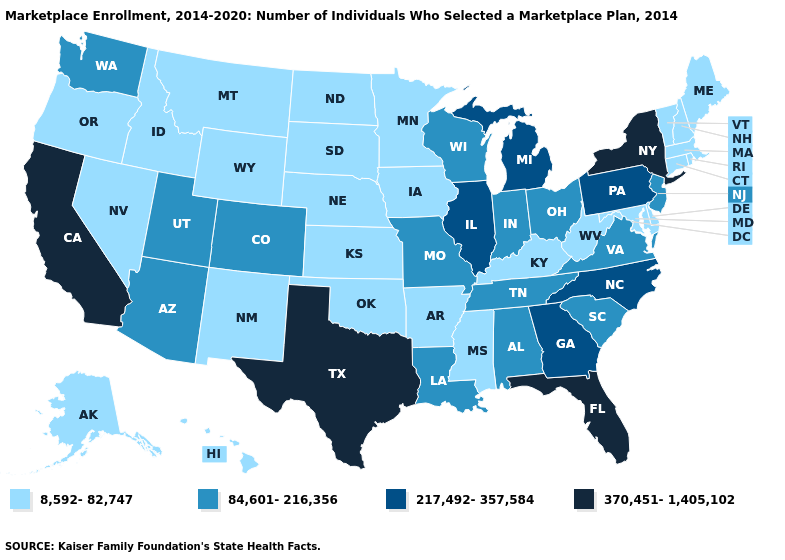What is the value of Alabama?
Answer briefly. 84,601-216,356. Which states hav the highest value in the South?
Write a very short answer. Florida, Texas. Among the states that border Colorado , does Oklahoma have the highest value?
Concise answer only. No. Which states have the lowest value in the MidWest?
Write a very short answer. Iowa, Kansas, Minnesota, Nebraska, North Dakota, South Dakota. Does the first symbol in the legend represent the smallest category?
Give a very brief answer. Yes. Does the first symbol in the legend represent the smallest category?
Keep it brief. Yes. What is the value of Iowa?
Answer briefly. 8,592-82,747. Name the states that have a value in the range 370,451-1,405,102?
Answer briefly. California, Florida, New York, Texas. What is the lowest value in states that border New Hampshire?
Write a very short answer. 8,592-82,747. What is the value of New York?
Concise answer only. 370,451-1,405,102. What is the value of Florida?
Concise answer only. 370,451-1,405,102. Does the map have missing data?
Write a very short answer. No. Among the states that border Wisconsin , which have the highest value?
Keep it brief. Illinois, Michigan. What is the value of Pennsylvania?
Quick response, please. 217,492-357,584. What is the highest value in states that border Iowa?
Write a very short answer. 217,492-357,584. 